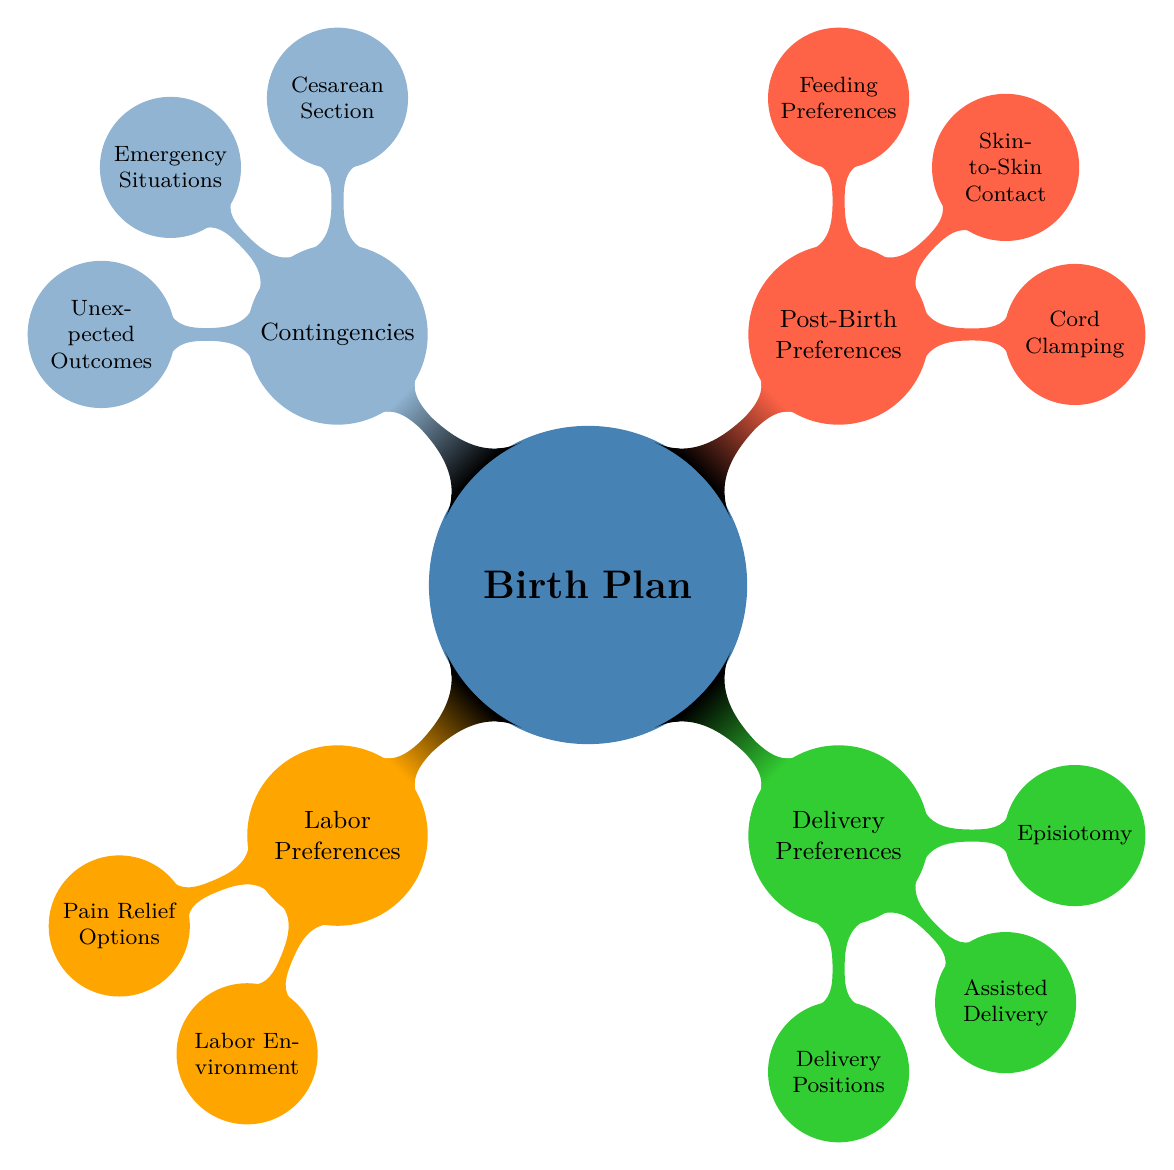What are the four pain relief options listed under Labor Preferences? The diagram shows the node "Pain Relief Options" within "Labor Preferences," which has four sub-nodes: "Epidural," "Nitrous Oxide," "IV Pain Medications," and "Natural Pain Relief (Breathing, Positioning)."
Answer: Epidural, Nitrous Oxide, IV Pain Medications, Natural Pain Relief (Breathing, Positioning) How many nodes are there under Delivery Preferences? The "Delivery Preferences" node has three child nodes which are "Delivery Positions," "Assisted Delivery," and "Episiotomy," totaling three nodes under this category.
Answer: 3 What preference is specified for skin-to-skin contact in Post-Birth Preferences? The diagram under "Post-Birth Preferences" specifies two options for "Skin-to-Skin Contact": "Immediately After Birth" and "After Initial Medical Checks," indicating a preference for immediate contact after birth.
Answer: Immediately After Birth What is the preferred method of anesthesia for a Cesarean Section? In the "Contingencies" section, under "Cesarean Section," there is a specified preference for "Spinal Anesthesia," indicating a specific choice for anesthesia during a cesarean delivery.
Answer: Prefer Spinal Anesthesia How are the post-birth preferences categorized in the diagram? The "Post-Birth Preferences" node has three main subcategories: "Cord Clamping," "Skin-to-Skin Contact," and "Feeding Preferences," organizing the post-birth options clearly under this node.
Answer: Cord Clamping, Skin-to-Skin Contact, Feeding Preferences What are two potential unexpected outcomes mentioned in the diagram? The "Contingencies" section includes the node "Unexpected Outcomes" which lists "Pediatrician on Call" and "Lactation Consultant Available," detailing preparations for unexpected scenarios.
Answer: Pediatrician on Call, Lactation Consultant Available Which delivery position is associated with the birthing experience? The "Delivery Positions" node under "Delivery Preferences" includes various options for delivery, indicating the focus on different positions that can be chosen during the birth process.
Answer: Squatting, Birthing Stool, Side-Lying, On Back What does the "Emergency Situations" node imply regarding hospital access? Within the "Contingencies" section, the node "Emergency Situations" contains "Preferred Hospital," indicating an option to choose a hospital specifically for emergencies.
Answer: Preferred Hospital 